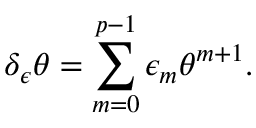Convert formula to latex. <formula><loc_0><loc_0><loc_500><loc_500>\delta _ { \epsilon } \theta = \sum _ { m = 0 } ^ { p - 1 } \epsilon _ { m } \theta ^ { m + 1 } .</formula> 